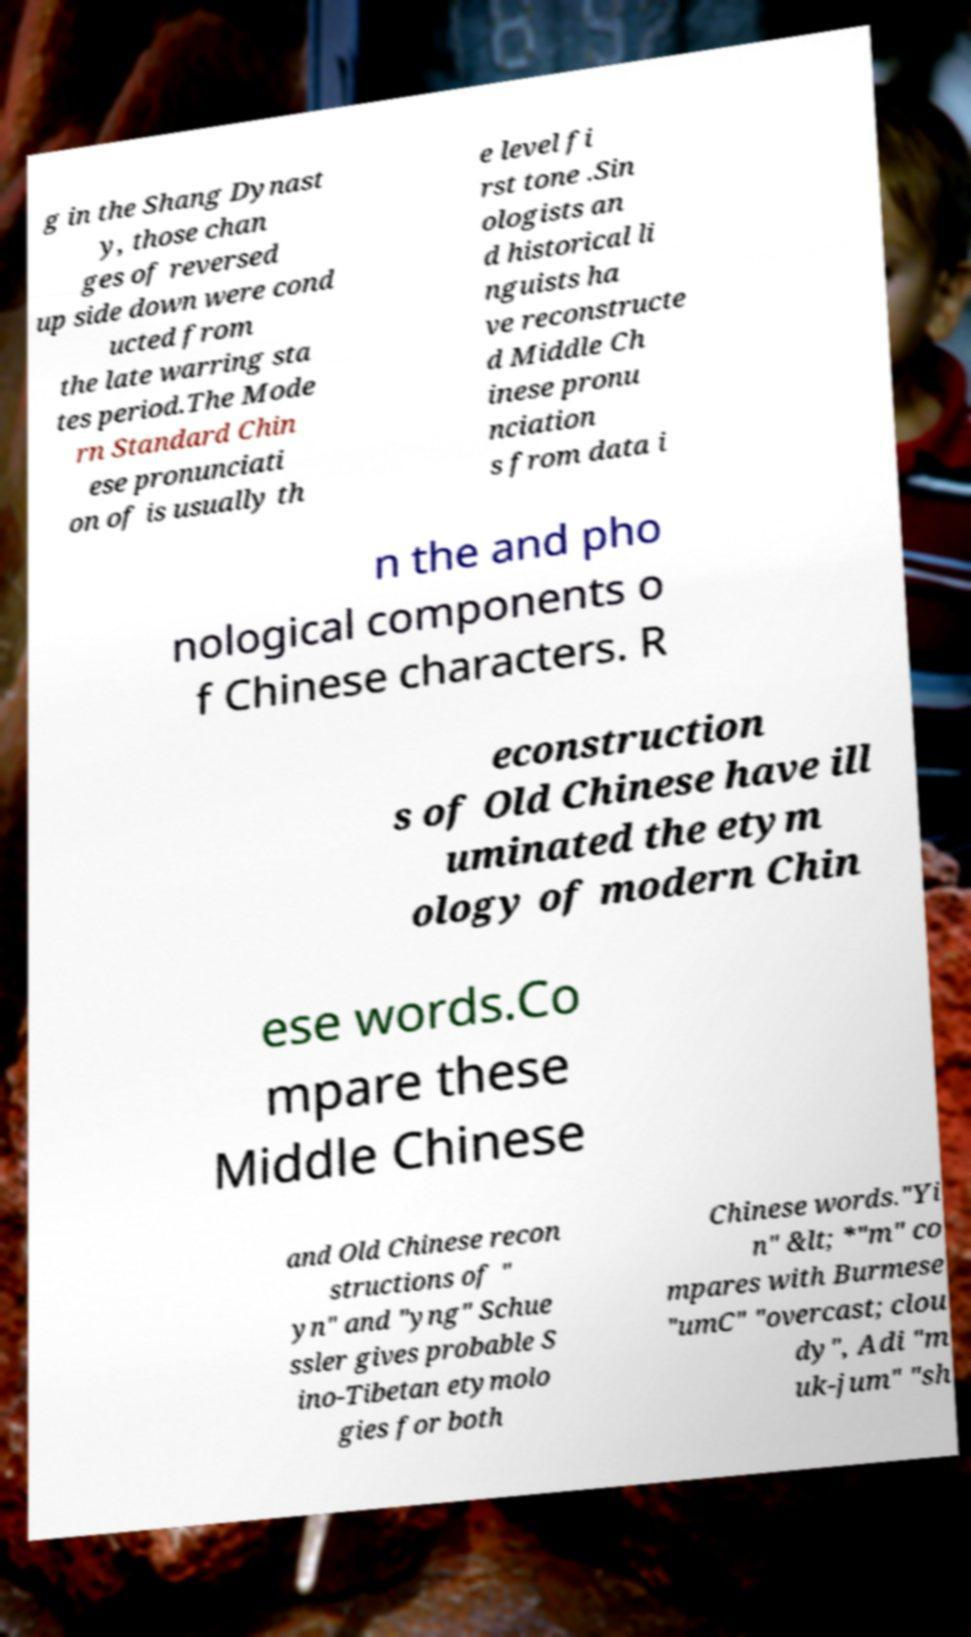There's text embedded in this image that I need extracted. Can you transcribe it verbatim? g in the Shang Dynast y, those chan ges of reversed up side down were cond ucted from the late warring sta tes period.The Mode rn Standard Chin ese pronunciati on of is usually th e level fi rst tone .Sin ologists an d historical li nguists ha ve reconstructe d Middle Ch inese pronu nciation s from data i n the and pho nological components o f Chinese characters. R econstruction s of Old Chinese have ill uminated the etym ology of modern Chin ese words.Co mpare these Middle Chinese and Old Chinese recon structions of " yn" and "yng" Schue ssler gives probable S ino-Tibetan etymolo gies for both Chinese words."Yi n" &lt; *"m" co mpares with Burmese "umC" "overcast; clou dy", Adi "m uk-jum" "sh 